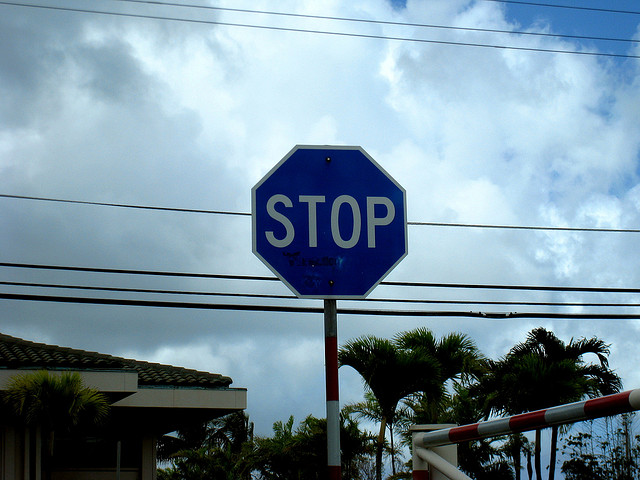Please transcribe the text information in this image. STOP 